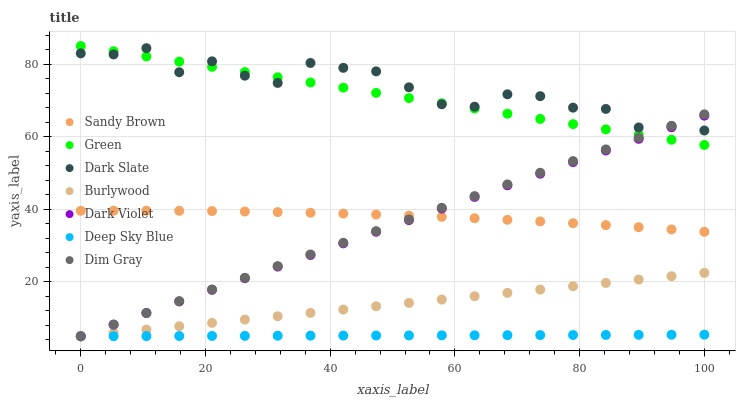Does Deep Sky Blue have the minimum area under the curve?
Answer yes or no. Yes. Does Dark Slate have the maximum area under the curve?
Answer yes or no. Yes. Does Burlywood have the minimum area under the curve?
Answer yes or no. No. Does Burlywood have the maximum area under the curve?
Answer yes or no. No. Is Deep Sky Blue the smoothest?
Answer yes or no. Yes. Is Dark Slate the roughest?
Answer yes or no. Yes. Is Burlywood the smoothest?
Answer yes or no. No. Is Burlywood the roughest?
Answer yes or no. No. Does Dim Gray have the lowest value?
Answer yes or no. Yes. Does Dark Slate have the lowest value?
Answer yes or no. No. Does Green have the highest value?
Answer yes or no. Yes. Does Burlywood have the highest value?
Answer yes or no. No. Is Sandy Brown less than Green?
Answer yes or no. Yes. Is Sandy Brown greater than Burlywood?
Answer yes or no. Yes. Does Dark Violet intersect Dark Slate?
Answer yes or no. Yes. Is Dark Violet less than Dark Slate?
Answer yes or no. No. Is Dark Violet greater than Dark Slate?
Answer yes or no. No. Does Sandy Brown intersect Green?
Answer yes or no. No. 